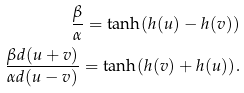Convert formula to latex. <formula><loc_0><loc_0><loc_500><loc_500>\frac { \beta } { \alpha } = \tanh ( h ( u ) - h ( v ) ) \\ \frac { \beta d ( u + v ) } { \alpha d ( u - v ) } = \tanh ( h ( v ) + h ( u ) ) .</formula> 